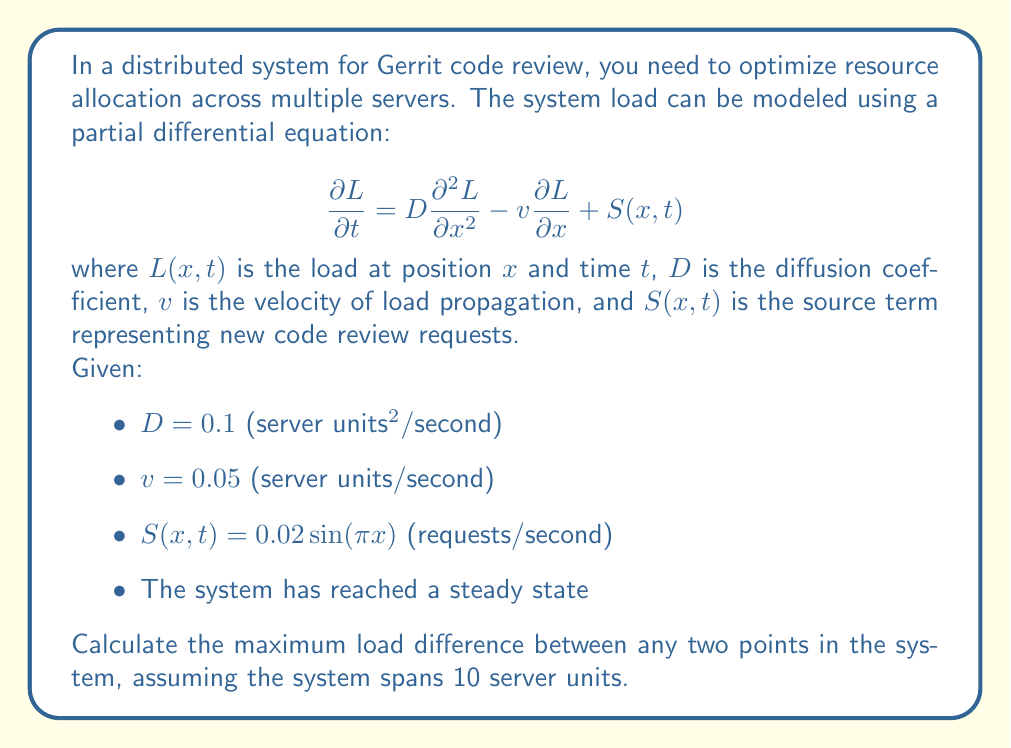Show me your answer to this math problem. To solve this problem, we need to follow these steps:

1) In steady state, $\frac{\partial L}{\partial t} = 0$, so our equation becomes:

   $$0 = D\frac{d^2 L}{dx^2} - v\frac{dL}{dx} + S(x)$$

2) Substituting the given values:

   $$0 = 0.1\frac{d^2 L}{dx^2} - 0.05\frac{dL}{dx} + 0.02\sin(\pi x)$$

3) To solve this, we can guess a solution of the form:

   $$L(x) = A\sin(\pi x) + B\cos(\pi x) + Cx + E$$

4) Substituting this into our equation:

   $$0 = 0.1(-A\pi^2\sin(\pi x) - B\pi^2\cos(\pi x)) - 0.05(A\pi\cos(\pi x) - B\pi\sin(\pi x) + C) + 0.02\sin(\pi x)$$

5) Equating coefficients:

   $\sin(\pi x)$: $-0.1A\pi^2 + 0.05B\pi + 0.02 = 0$
   $\cos(\pi x)$: $-0.1B\pi^2 - 0.05A\pi = 0$
   Constant: $-0.05C = 0$

6) Solving these equations:

   $C = 0$
   $A = \frac{0.02}{0.1\pi^2} = \frac{0.2}{\pi^2} \approx 0.0203$
   $B = -\frac{0.05A\pi}{0.1\pi^2} = -\frac{0.1}{\pi} \approx -0.0318$

7) Therefore, our solution is:

   $$L(x) = 0.0203\sin(\pi x) - 0.0318\cos(\pi x) + E$$

8) The maximum load difference will occur between the maximum and minimum of this function over the interval [0, 10].

9) To find these, we differentiate:

   $$\frac{dL}{dx} = 0.0203\pi\cos(\pi x) + 0.0318\pi\sin(\pi x)$$

   Set this to zero and solve:

   $$x = \frac{1}{\pi}\tan^{-1}(-\frac{0.0203}{0.0318}) + \frac{n}{2}, n \in \mathbb{Z}$$

10) The extrema occur at $x \approx 0.39$ and $x \approx 1.39$ (and repeating every 1 unit).

11) Evaluating $L(x)$ at these points:

    $L(0.39) \approx -0.0318 + E$
    $L(1.39) \approx 0.0318 + E$

12) The maximum load difference is therefore:

    $0.0318 - (-0.0318) = 0.0636$
Answer: The maximum load difference between any two points in the system is approximately 0.0636 (load units). 